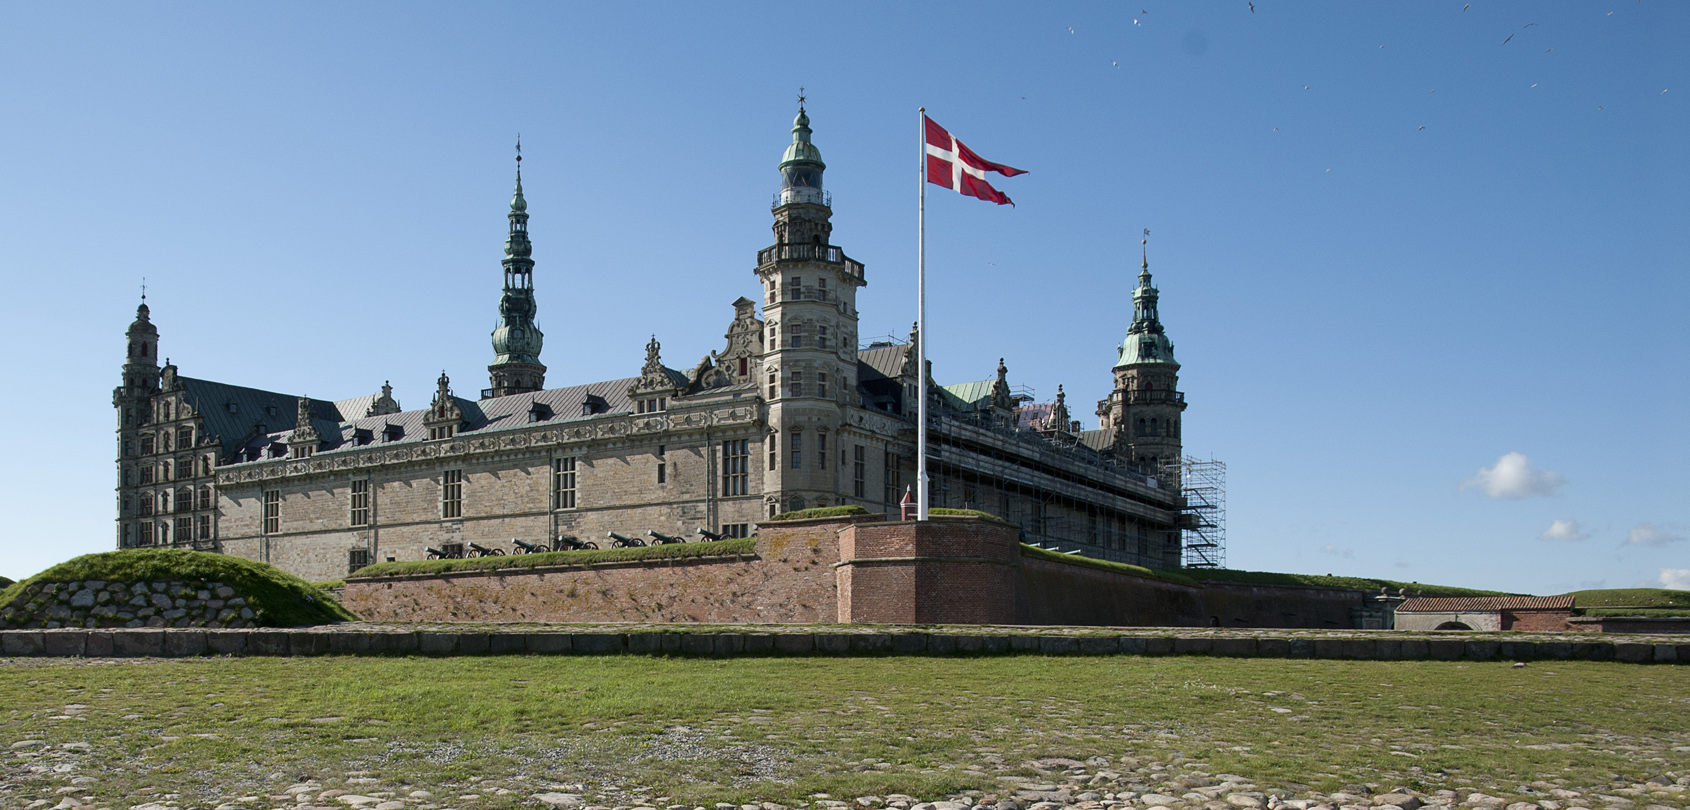Write a short creative story inspired by the image of the castle. In the serene town of Helsingør, there stood an ancient castle named Kronborg, where the echoes of history whispered through its towering spires and shadowy corridors. Legend had it that every full moon, the spirits of past kings and queens would gather in the grand hall, reliving their glorious days. One night, a young girl named Lise, drawn by an ethereal glow, discovered a secret passage beneath the castle. As she ventured through, the walls began to shimmer, morphing into scenes from centuries past. Kings planned battles, queens danced in splendid balls, and soldiers stood guard, ever vigilant. In the heart of the passage, she found a forgotten room containing an old, dusty crown. As she touched it, the spirits around her began to fade, leaving behind only the stories woven into the very stones of Kronborg. From that night onward, every full moon, Lise felt a gentle tug towards the castle, as if it was calling her to unlock more of its timeless tales. 